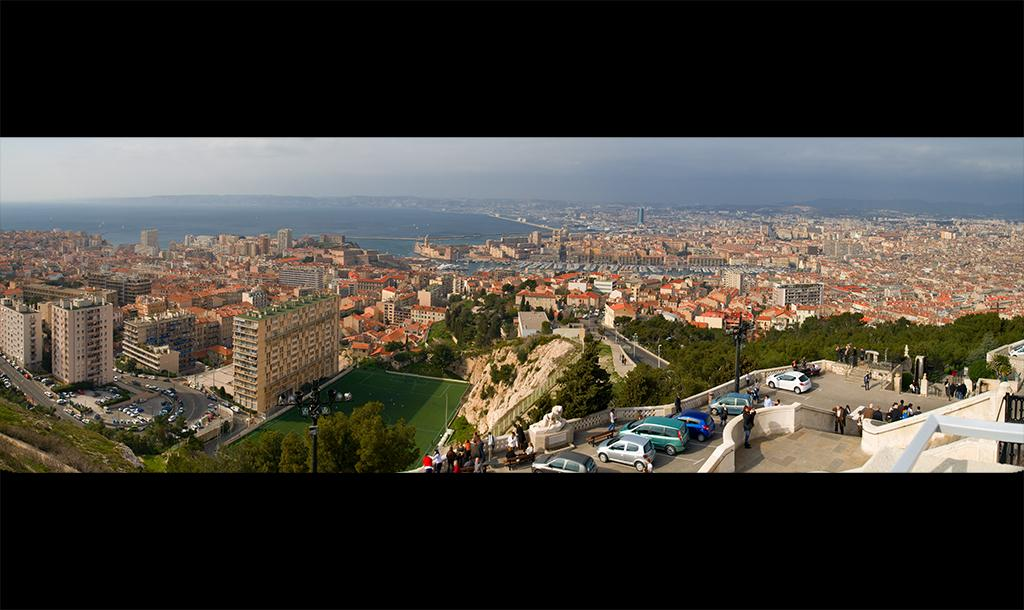What type of structures are present in the image? There are buildings in the image. What other natural elements can be seen in the image? There are trees in the image. Are there any human figures in the image? Yes, there are people in the image. What are the poles in the image used for? The poles in the image are likely used for supporting street lights or other infrastructure. What can be seen in the background of the image? The sky and water are visible in the background of the image. Which actor plays the main character in the movie depicted in the image? There is no movie depicted in the image, so it is not possible to identify an actor or character. 